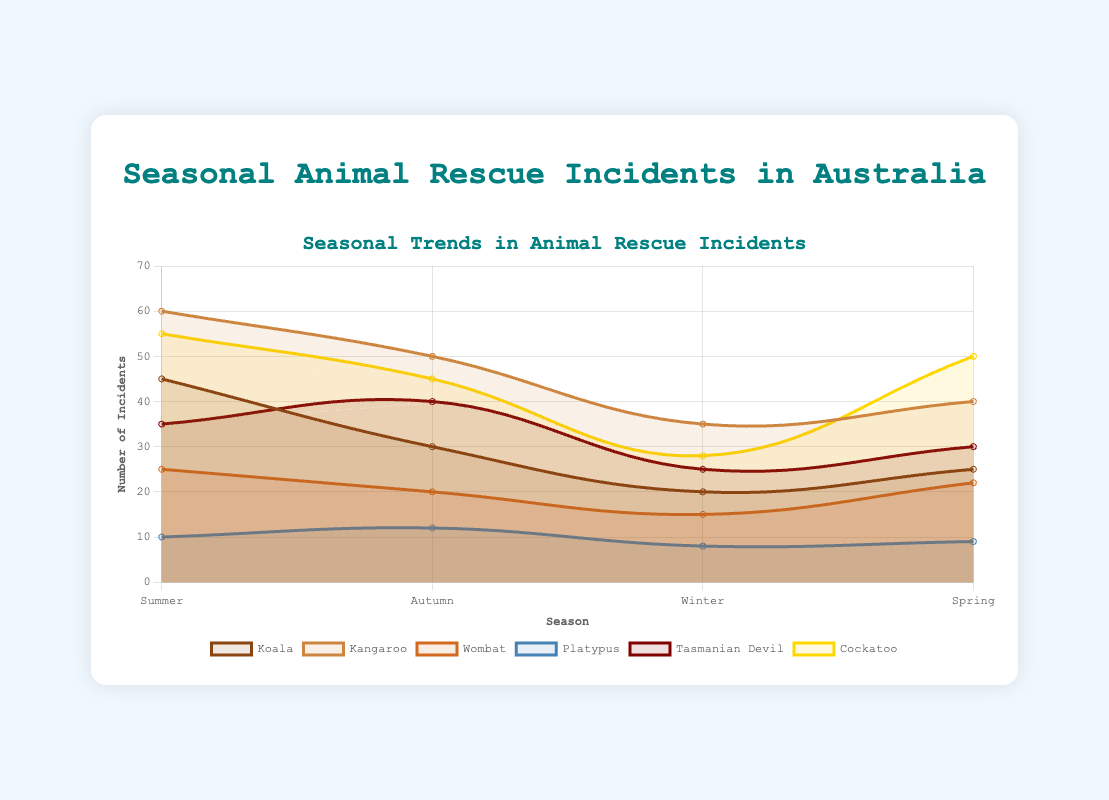What's the species with the highest number of rescue incidents in Summer? By looking at the highest data point for the Summer season among the species, we see that Kangaroos have 60 incidents, which is the highest.
Answer: Kangaroo In which season does Koala experience the lowest number of rescue incidents? Checking the data points for Koalas across all seasons, the lowest number of incidents is in Winter with 20 incidents.
Answer: Winter Does Platypus experience a higher number of rescue incidents in Autumn than in Spring? Comparing the Platypus rescue incidents in Autumn (12 incidents) with Spring (9 incidents) shows that Autumn has a higher number.
Answer: Yes What is the average number of rescue incidents for Cockatoos across all seasons? Adding Cockatoo incidents for each season: (55 + 45 + 28 + 50) = 178, then dividing by 4 seasons, we get 178 / 4 = 44.5.
Answer: 44.5 Which species shows the most significant decrease in rescue incidents from Summer to Winter? For each species, calculate the difference from Summer to Winter: Koala (45-20=25), Kangaroo (60-35=25), Wombat (25-15=10), Platypus (10-8=2), Tasmanian Devil (35-25=10), Cockatoo (55-28=27). The Cockatoo shows the most significant decrease.
Answer: Cockatoo How many more rescue incidents are there for Kangaroos in Spring compared to Winter? Subtract the number of incidents for Kangaroos in Winter from those in Spring: 40 (Spring) - 35 (Winter) = 5.
Answer: 5 During which season does the Tasmanian Devil have the highest number of rescue incidents? Looking at the data points for the Tasmanian Devil, Autumn has the highest number of incidents (40).
Answer: Autumn By what percentage do rescue incidents for Wombats increase from Winter to Spring? Calculate the increase in Wombat incidents from Winter to Spring: 22 (Spring) - 15 (Winter) = 7. To find the percentage increase: (7/15) * 100 ≈ 46.67%.
Answer: ~46.67% Which two species have identical number of rescue incidents during Autumn? By looking at the incidents for each species in Autumn, Koala and Wombat both have 20 incidents.
Answer: Koala and Wombat Overall, which season tends to have the highest number of rescue incidents for most species? Observing the trends across species, Summer has the highest incidents for Kolala, Kangaroo, Wombat, Platypus, and Cockatoo, indicating it tends to have the most incidents.
Answer: Summer 